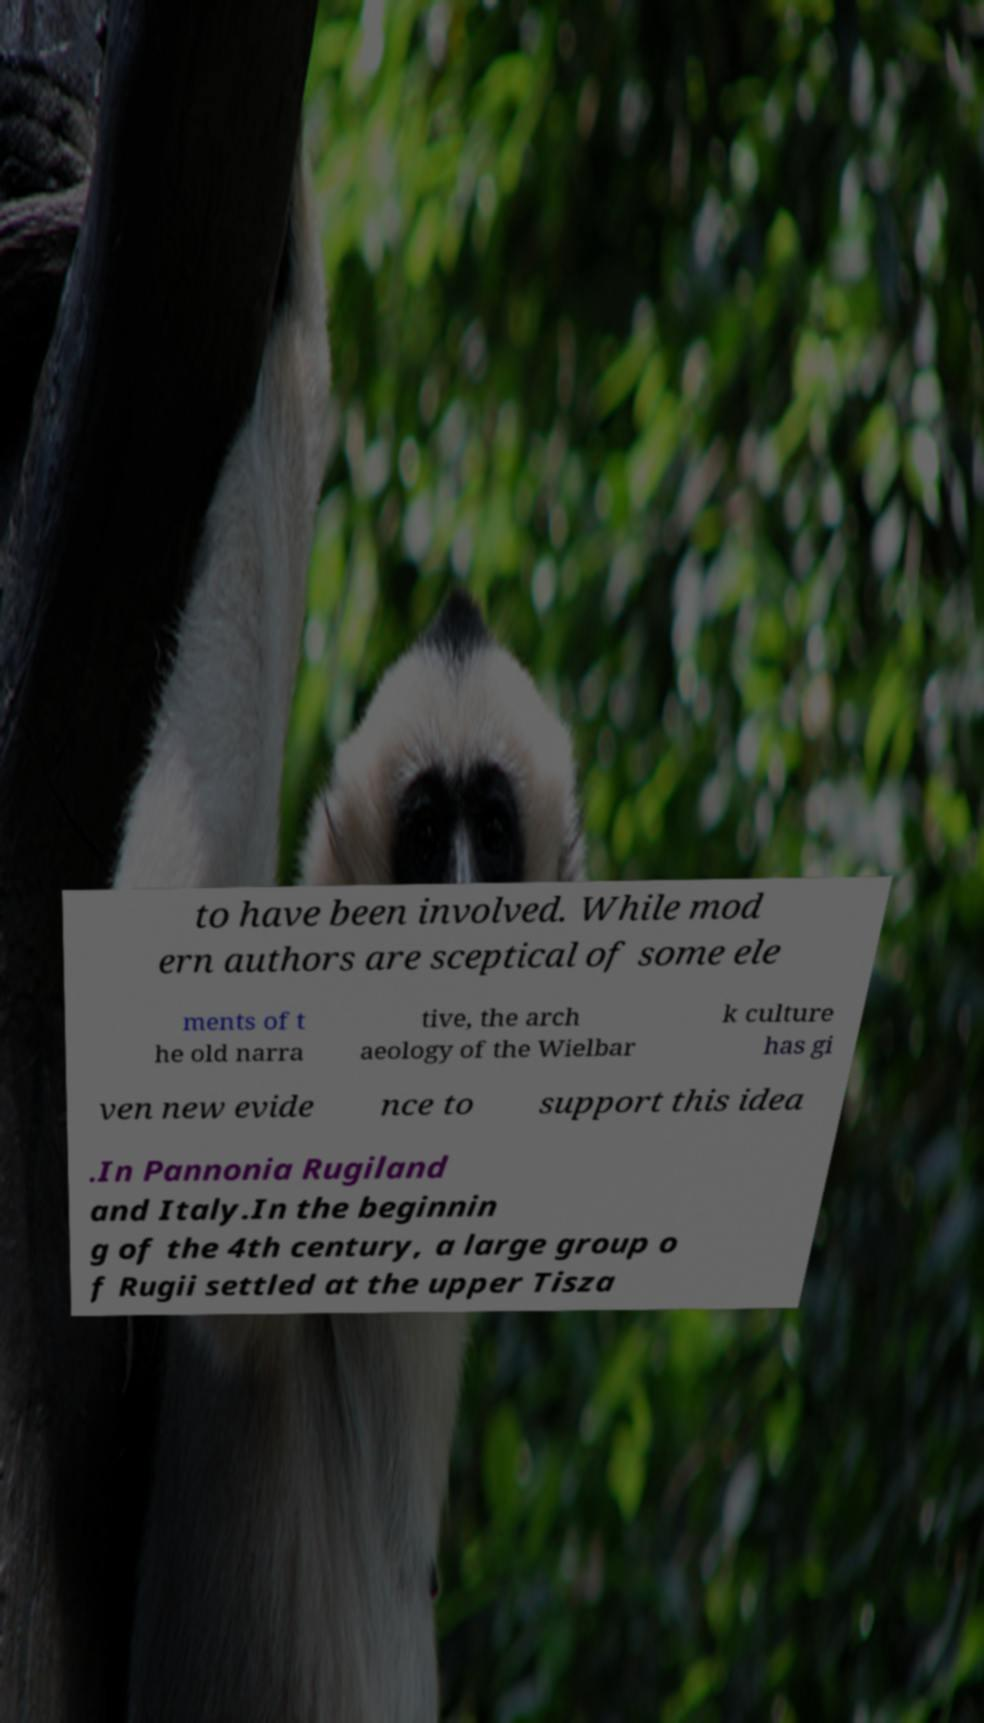Please identify and transcribe the text found in this image. to have been involved. While mod ern authors are sceptical of some ele ments of t he old narra tive, the arch aeology of the Wielbar k culture has gi ven new evide nce to support this idea .In Pannonia Rugiland and Italy.In the beginnin g of the 4th century, a large group o f Rugii settled at the upper Tisza 